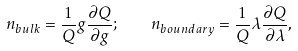<formula> <loc_0><loc_0><loc_500><loc_500>n _ { b u l k } = \frac { 1 } { Q } g \frac { \partial Q } { \partial g } ; \quad n _ { b o u n d a r y } = \frac { 1 } { Q } \lambda \frac { \partial Q } { \partial \lambda } ,</formula> 